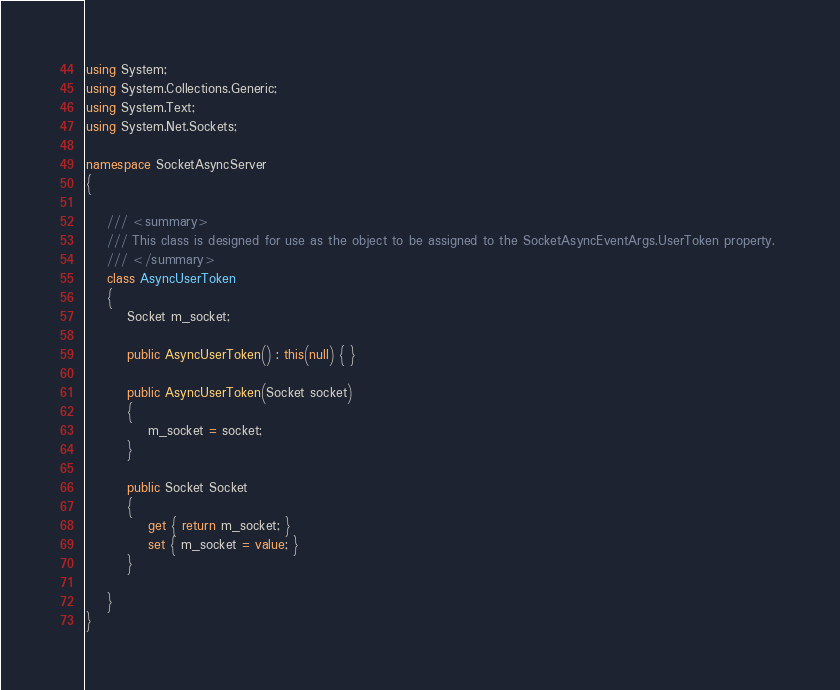<code> <loc_0><loc_0><loc_500><loc_500><_C#_>using System;
using System.Collections.Generic;
using System.Text;
using System.Net.Sockets;

namespace SocketAsyncServer
{

    /// <summary>
    /// This class is designed for use as the object to be assigned to the SocketAsyncEventArgs.UserToken property. 
    /// </summary>
    class AsyncUserToken
    {
        Socket m_socket;

        public AsyncUserToken() : this(null) { }

        public AsyncUserToken(Socket socket)
        {
            m_socket = socket;
        }

        public Socket Socket
        {
            get { return m_socket; }
            set { m_socket = value; }
        }

    }
}
</code> 